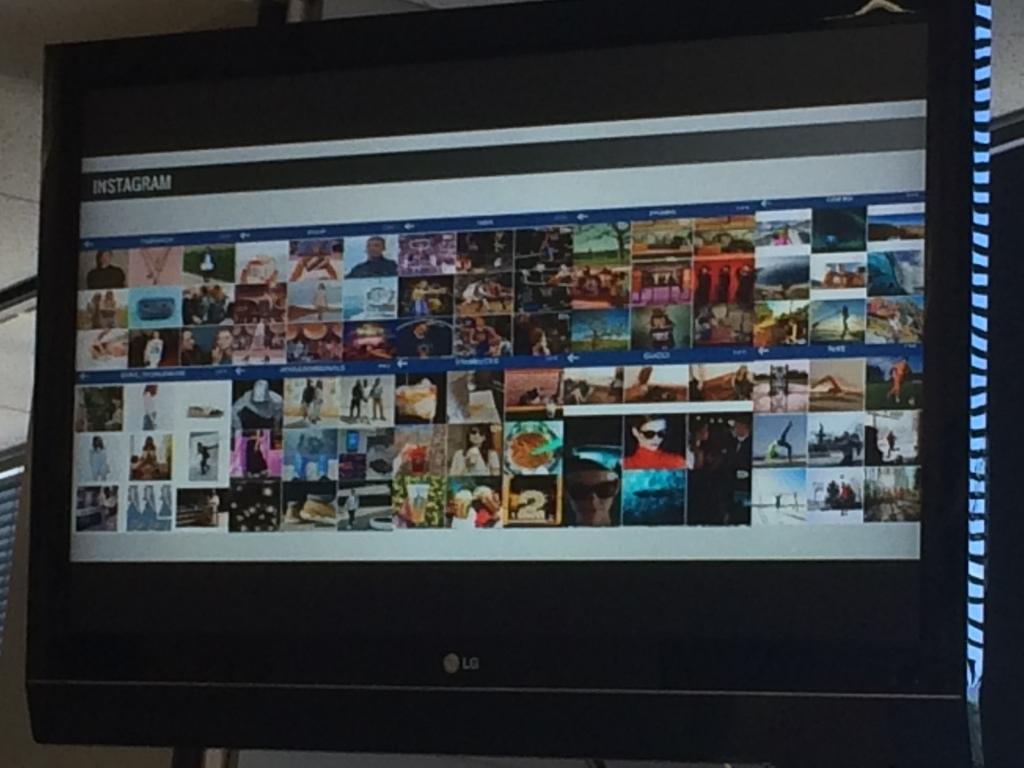What website is the user on?
Ensure brevity in your answer.  Instagram. What is the first letter of the name of the website?
Ensure brevity in your answer.  I. 